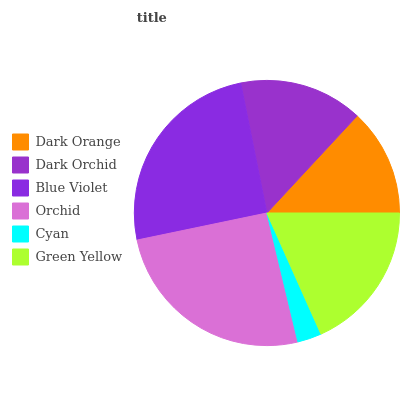Is Cyan the minimum?
Answer yes or no. Yes. Is Orchid the maximum?
Answer yes or no. Yes. Is Dark Orchid the minimum?
Answer yes or no. No. Is Dark Orchid the maximum?
Answer yes or no. No. Is Dark Orchid greater than Dark Orange?
Answer yes or no. Yes. Is Dark Orange less than Dark Orchid?
Answer yes or no. Yes. Is Dark Orange greater than Dark Orchid?
Answer yes or no. No. Is Dark Orchid less than Dark Orange?
Answer yes or no. No. Is Green Yellow the high median?
Answer yes or no. Yes. Is Dark Orchid the low median?
Answer yes or no. Yes. Is Dark Orchid the high median?
Answer yes or no. No. Is Green Yellow the low median?
Answer yes or no. No. 